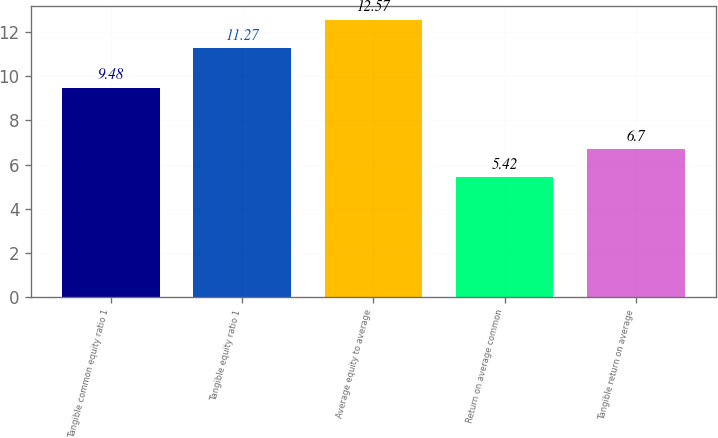<chart> <loc_0><loc_0><loc_500><loc_500><bar_chart><fcel>Tangible common equity ratio 1<fcel>Tangible equity ratio 1<fcel>Average equity to average<fcel>Return on average common<fcel>Tangible return on average<nl><fcel>9.48<fcel>11.27<fcel>12.57<fcel>5.42<fcel>6.7<nl></chart> 